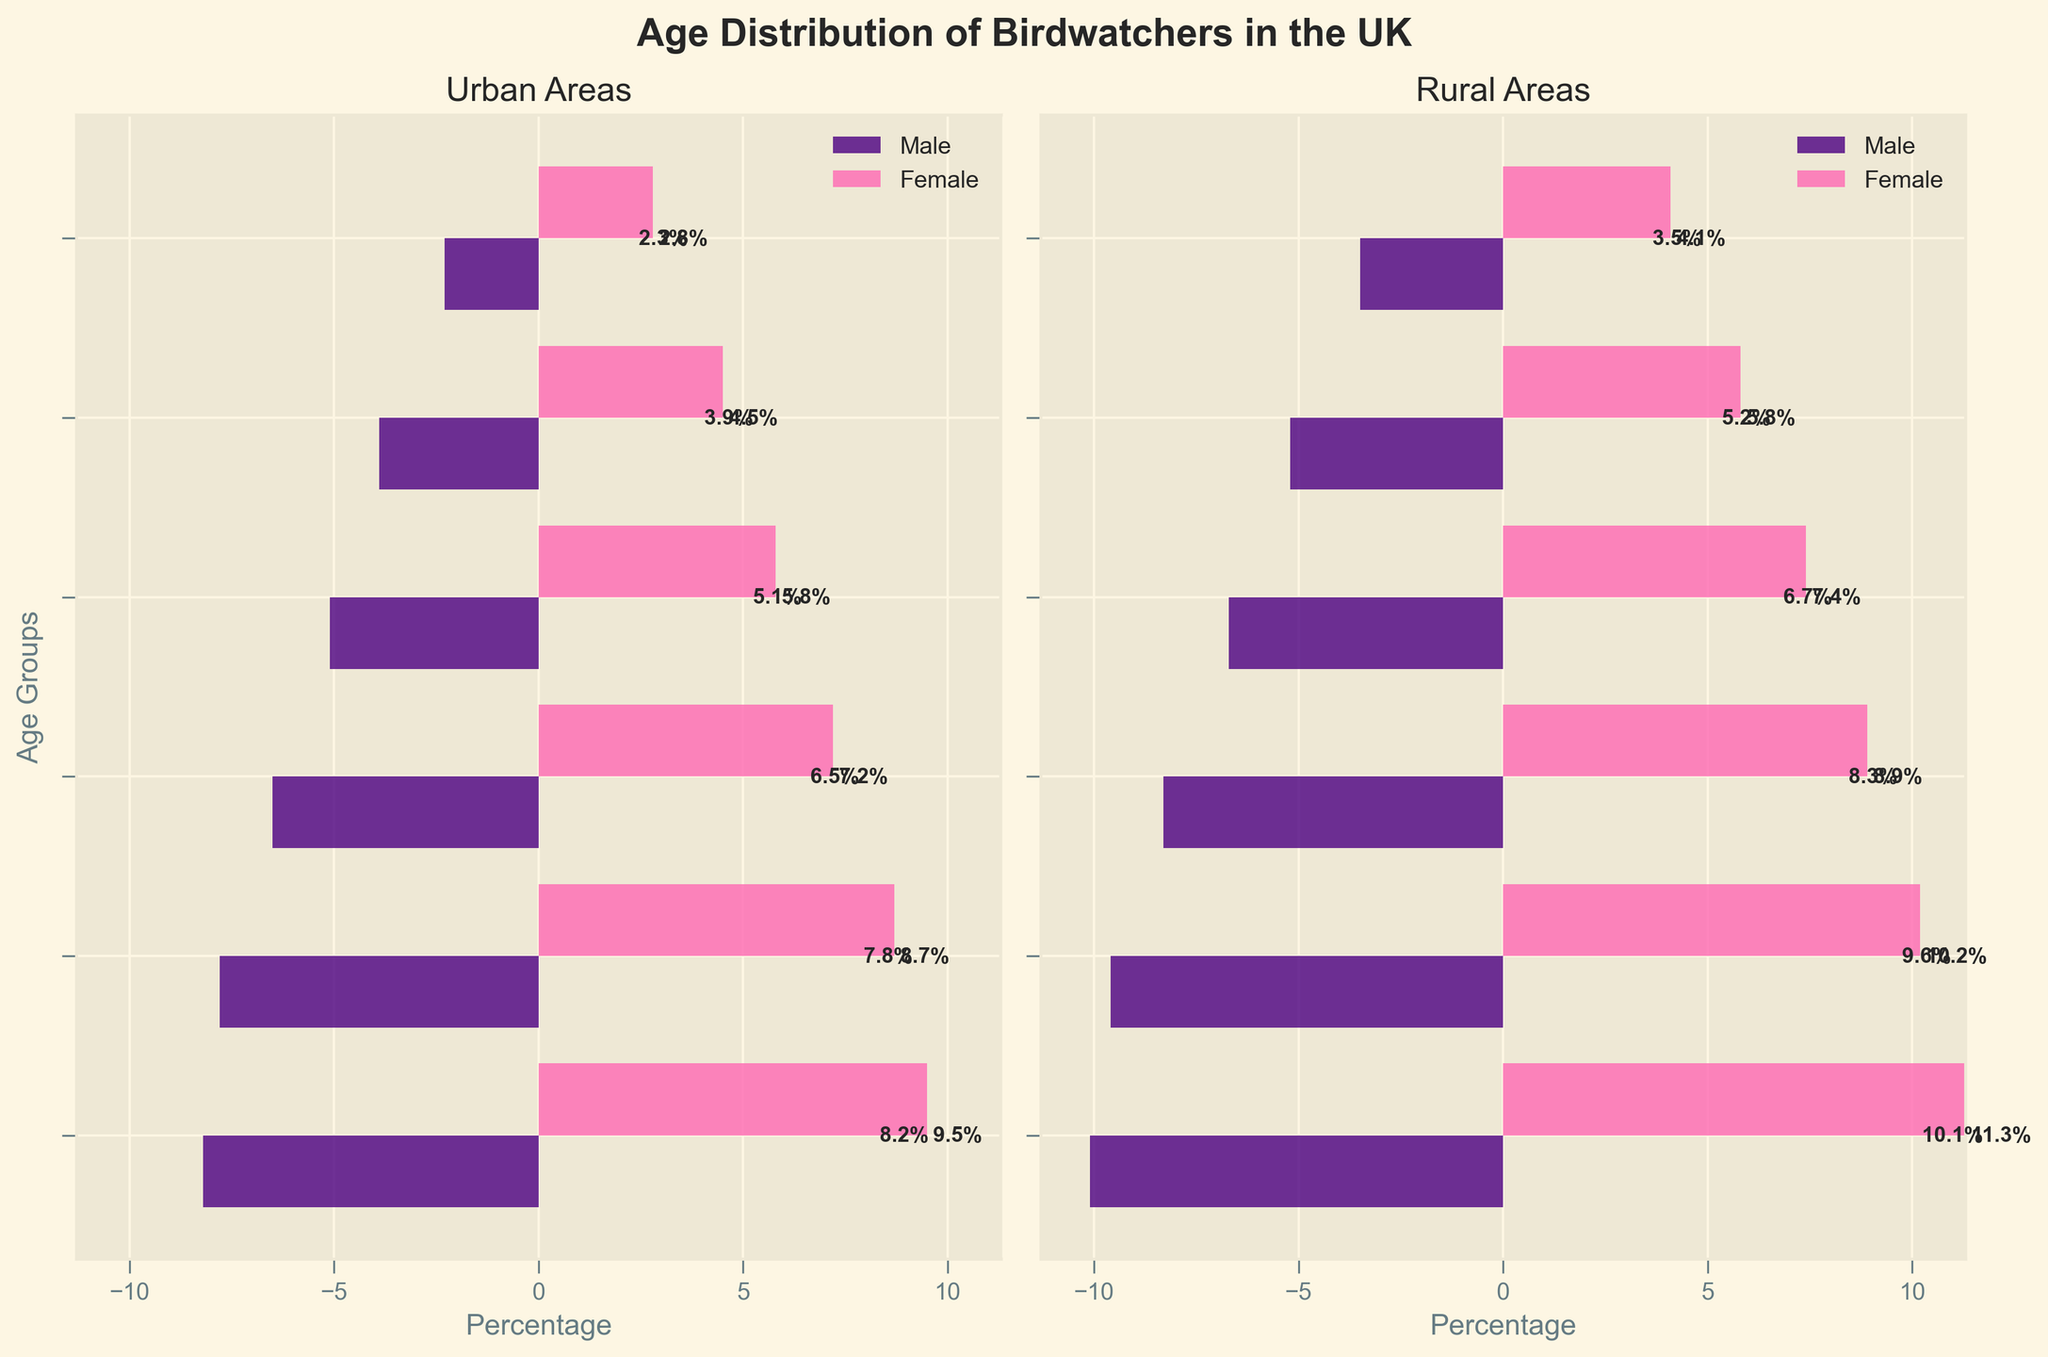What is the title of the figure? The title of the figure is displayed at the top and is meant to provide an overview of the chart's subject matter. It reads "Age Distribution of Birdwatchers in the UK."
Answer: Age Distribution of Birdwatchers in the UK What color represents urban male birdwatchers in the figure? Urban male birdwatchers are represented by the color used in the horizontal bars on the urban side of the pyramid. These bars are colored in a shade of indigo.
Answer: Indigo Which age group has the highest percentage of rural female birdwatchers? The figure assigns specific lengths to bars representing percentage values. The longest bar on the rural female side corresponds to the age group "65+."
Answer: 65+ Who has a higher percentage in the 45-54 age group, urban males or rural males? By visually comparing the lengths of the bars for the 45-54 age group, the rural male percentage bar extends further than the urban male percentage bar, indicating rural males have a higher percentage.
Answer: Rural males Which has more percentage of birdwatchers aged 18-24, urban females or rural females? By comparing the bars for each demographic for the 18-24 age group, the rural female bar is noticeably longer, indicating a higher percentage.
Answer: Rural females What is the percentage difference between urban and rural males in the 35-44 age group? From the figure, locate the bars for urban and rural males in the 35-44 age group. Subtract the urban male percentage (5.1%) from the rural male percentage (6.7%) to get the difference.
Answer: 1.6% In which type of area (urban or rural) do older populations (65+) make up a greater percentage of birdwatchers? The bars representing the 65+ age group on both the urban and rural sides should be compared. The rural bars (10.1% for males and 11.3% for females) are longer than the urban bars (8.2% for males and 9.5% for females), indicating a greater percentage in rural areas.
Answer: Rural On the urban side, which gender has a higher percentage for the age group 25-34? By comparing the bars for urban males and females in the 25-34 age group, the bar for urban females is longer, indicating a higher percentage.
Answer: Females What is the combined percentage of rural birdwatchers aged 55-64? Summing up the lengths of the bars for rural males (9.6%) and rural females (10.2%) in the 55-64 age group gives the combined percentage.
Answer: 19.8% Which age group has the smallest percentage of birdwatchers in urban areas? By observing the bar lengths for all age groups on the urban side, the bars for the 18-24 age group (2.3% for males and 2.8% for females) are the shortest, indicating the smallest percentage.
Answer: 18-24 